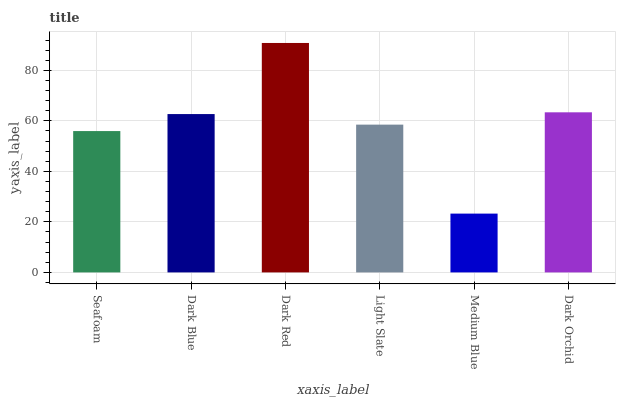Is Medium Blue the minimum?
Answer yes or no. Yes. Is Dark Red the maximum?
Answer yes or no. Yes. Is Dark Blue the minimum?
Answer yes or no. No. Is Dark Blue the maximum?
Answer yes or no. No. Is Dark Blue greater than Seafoam?
Answer yes or no. Yes. Is Seafoam less than Dark Blue?
Answer yes or no. Yes. Is Seafoam greater than Dark Blue?
Answer yes or no. No. Is Dark Blue less than Seafoam?
Answer yes or no. No. Is Dark Blue the high median?
Answer yes or no. Yes. Is Light Slate the low median?
Answer yes or no. Yes. Is Dark Orchid the high median?
Answer yes or no. No. Is Dark Blue the low median?
Answer yes or no. No. 